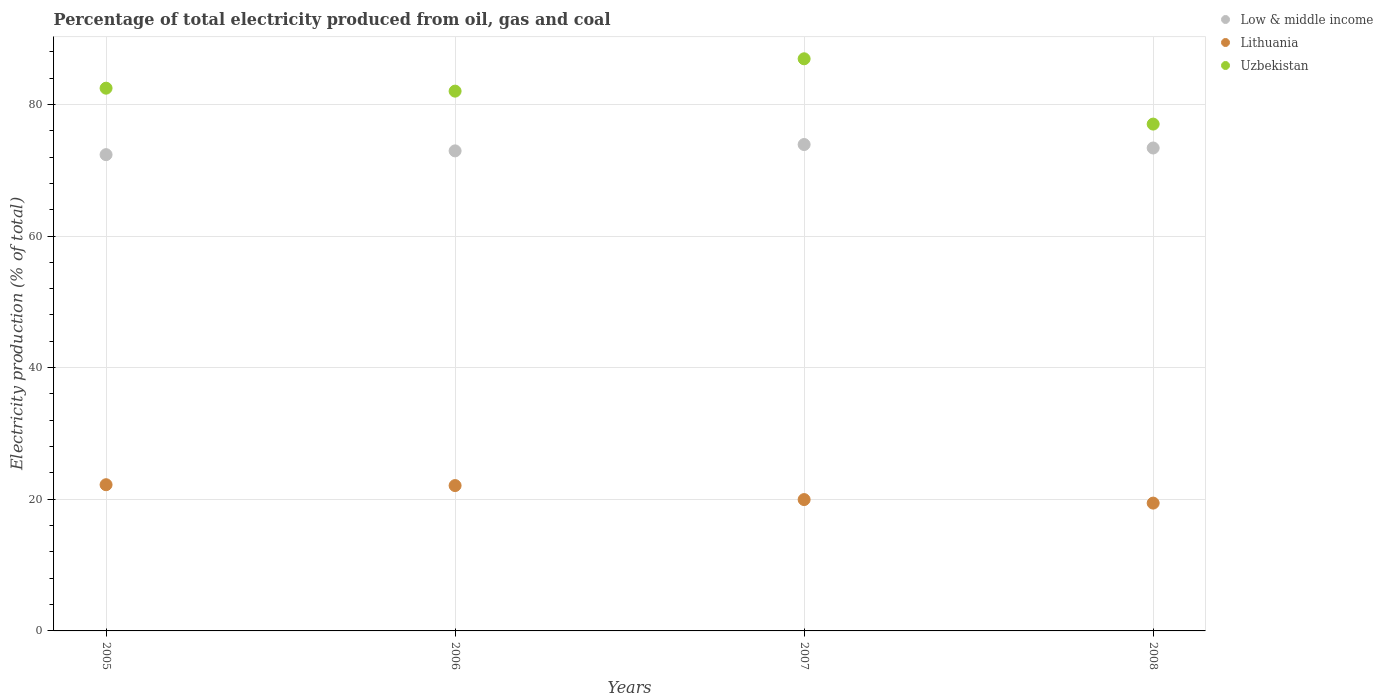Is the number of dotlines equal to the number of legend labels?
Your response must be concise. Yes. What is the electricity production in in Uzbekistan in 2005?
Offer a very short reply. 82.46. Across all years, what is the maximum electricity production in in Lithuania?
Keep it short and to the point. 22.21. Across all years, what is the minimum electricity production in in Lithuania?
Ensure brevity in your answer.  19.42. What is the total electricity production in in Uzbekistan in the graph?
Your answer should be very brief. 328.4. What is the difference between the electricity production in in Uzbekistan in 2007 and that in 2008?
Your answer should be very brief. 9.92. What is the difference between the electricity production in in Low & middle income in 2005 and the electricity production in in Uzbekistan in 2008?
Offer a very short reply. -4.64. What is the average electricity production in in Lithuania per year?
Your response must be concise. 20.92. In the year 2008, what is the difference between the electricity production in in Low & middle income and electricity production in in Lithuania?
Provide a succinct answer. 53.95. What is the ratio of the electricity production in in Low & middle income in 2005 to that in 2006?
Ensure brevity in your answer.  0.99. Is the electricity production in in Uzbekistan in 2005 less than that in 2006?
Keep it short and to the point. No. Is the difference between the electricity production in in Low & middle income in 2005 and 2006 greater than the difference between the electricity production in in Lithuania in 2005 and 2006?
Provide a succinct answer. No. What is the difference between the highest and the second highest electricity production in in Low & middle income?
Keep it short and to the point. 0.53. What is the difference between the highest and the lowest electricity production in in Lithuania?
Offer a very short reply. 2.79. Is it the case that in every year, the sum of the electricity production in in Uzbekistan and electricity production in in Low & middle income  is greater than the electricity production in in Lithuania?
Provide a short and direct response. Yes. Does the electricity production in in Low & middle income monotonically increase over the years?
Give a very brief answer. No. How many years are there in the graph?
Provide a succinct answer. 4. Does the graph contain any zero values?
Keep it short and to the point. No. Where does the legend appear in the graph?
Your response must be concise. Top right. How are the legend labels stacked?
Ensure brevity in your answer.  Vertical. What is the title of the graph?
Your answer should be compact. Percentage of total electricity produced from oil, gas and coal. Does "Senegal" appear as one of the legend labels in the graph?
Provide a short and direct response. No. What is the label or title of the Y-axis?
Make the answer very short. Electricity production (% of total). What is the Electricity production (% of total) of Low & middle income in 2005?
Your response must be concise. 72.36. What is the Electricity production (% of total) of Lithuania in 2005?
Ensure brevity in your answer.  22.21. What is the Electricity production (% of total) in Uzbekistan in 2005?
Provide a succinct answer. 82.46. What is the Electricity production (% of total) in Low & middle income in 2006?
Your response must be concise. 72.94. What is the Electricity production (% of total) in Lithuania in 2006?
Your answer should be compact. 22.08. What is the Electricity production (% of total) of Uzbekistan in 2006?
Make the answer very short. 82.01. What is the Electricity production (% of total) in Low & middle income in 2007?
Give a very brief answer. 73.9. What is the Electricity production (% of total) of Lithuania in 2007?
Offer a very short reply. 19.96. What is the Electricity production (% of total) of Uzbekistan in 2007?
Offer a terse response. 86.93. What is the Electricity production (% of total) of Low & middle income in 2008?
Your answer should be very brief. 73.37. What is the Electricity production (% of total) in Lithuania in 2008?
Make the answer very short. 19.42. What is the Electricity production (% of total) in Uzbekistan in 2008?
Offer a very short reply. 77. Across all years, what is the maximum Electricity production (% of total) in Low & middle income?
Your answer should be compact. 73.9. Across all years, what is the maximum Electricity production (% of total) in Lithuania?
Your answer should be compact. 22.21. Across all years, what is the maximum Electricity production (% of total) of Uzbekistan?
Offer a very short reply. 86.93. Across all years, what is the minimum Electricity production (% of total) in Low & middle income?
Keep it short and to the point. 72.36. Across all years, what is the minimum Electricity production (% of total) in Lithuania?
Keep it short and to the point. 19.42. Across all years, what is the minimum Electricity production (% of total) in Uzbekistan?
Offer a terse response. 77. What is the total Electricity production (% of total) in Low & middle income in the graph?
Give a very brief answer. 292.57. What is the total Electricity production (% of total) in Lithuania in the graph?
Make the answer very short. 83.67. What is the total Electricity production (% of total) of Uzbekistan in the graph?
Provide a succinct answer. 328.4. What is the difference between the Electricity production (% of total) of Low & middle income in 2005 and that in 2006?
Provide a short and direct response. -0.57. What is the difference between the Electricity production (% of total) of Lithuania in 2005 and that in 2006?
Provide a short and direct response. 0.13. What is the difference between the Electricity production (% of total) in Uzbekistan in 2005 and that in 2006?
Offer a very short reply. 0.45. What is the difference between the Electricity production (% of total) of Low & middle income in 2005 and that in 2007?
Give a very brief answer. -1.54. What is the difference between the Electricity production (% of total) of Lithuania in 2005 and that in 2007?
Ensure brevity in your answer.  2.26. What is the difference between the Electricity production (% of total) in Uzbekistan in 2005 and that in 2007?
Ensure brevity in your answer.  -4.47. What is the difference between the Electricity production (% of total) of Low & middle income in 2005 and that in 2008?
Offer a very short reply. -1.01. What is the difference between the Electricity production (% of total) of Lithuania in 2005 and that in 2008?
Your answer should be very brief. 2.79. What is the difference between the Electricity production (% of total) of Uzbekistan in 2005 and that in 2008?
Your answer should be compact. 5.46. What is the difference between the Electricity production (% of total) of Low & middle income in 2006 and that in 2007?
Provide a short and direct response. -0.96. What is the difference between the Electricity production (% of total) in Lithuania in 2006 and that in 2007?
Give a very brief answer. 2.13. What is the difference between the Electricity production (% of total) in Uzbekistan in 2006 and that in 2007?
Provide a succinct answer. -4.91. What is the difference between the Electricity production (% of total) in Low & middle income in 2006 and that in 2008?
Provide a succinct answer. -0.44. What is the difference between the Electricity production (% of total) of Lithuania in 2006 and that in 2008?
Ensure brevity in your answer.  2.66. What is the difference between the Electricity production (% of total) in Uzbekistan in 2006 and that in 2008?
Offer a very short reply. 5.01. What is the difference between the Electricity production (% of total) of Low & middle income in 2007 and that in 2008?
Your response must be concise. 0.53. What is the difference between the Electricity production (% of total) of Lithuania in 2007 and that in 2008?
Provide a short and direct response. 0.54. What is the difference between the Electricity production (% of total) of Uzbekistan in 2007 and that in 2008?
Your response must be concise. 9.92. What is the difference between the Electricity production (% of total) in Low & middle income in 2005 and the Electricity production (% of total) in Lithuania in 2006?
Provide a short and direct response. 50.28. What is the difference between the Electricity production (% of total) in Low & middle income in 2005 and the Electricity production (% of total) in Uzbekistan in 2006?
Your response must be concise. -9.65. What is the difference between the Electricity production (% of total) of Lithuania in 2005 and the Electricity production (% of total) of Uzbekistan in 2006?
Offer a very short reply. -59.8. What is the difference between the Electricity production (% of total) in Low & middle income in 2005 and the Electricity production (% of total) in Lithuania in 2007?
Ensure brevity in your answer.  52.41. What is the difference between the Electricity production (% of total) of Low & middle income in 2005 and the Electricity production (% of total) of Uzbekistan in 2007?
Provide a succinct answer. -14.56. What is the difference between the Electricity production (% of total) of Lithuania in 2005 and the Electricity production (% of total) of Uzbekistan in 2007?
Offer a very short reply. -64.71. What is the difference between the Electricity production (% of total) of Low & middle income in 2005 and the Electricity production (% of total) of Lithuania in 2008?
Make the answer very short. 52.94. What is the difference between the Electricity production (% of total) of Low & middle income in 2005 and the Electricity production (% of total) of Uzbekistan in 2008?
Ensure brevity in your answer.  -4.64. What is the difference between the Electricity production (% of total) of Lithuania in 2005 and the Electricity production (% of total) of Uzbekistan in 2008?
Keep it short and to the point. -54.79. What is the difference between the Electricity production (% of total) in Low & middle income in 2006 and the Electricity production (% of total) in Lithuania in 2007?
Make the answer very short. 52.98. What is the difference between the Electricity production (% of total) in Low & middle income in 2006 and the Electricity production (% of total) in Uzbekistan in 2007?
Offer a very short reply. -13.99. What is the difference between the Electricity production (% of total) of Lithuania in 2006 and the Electricity production (% of total) of Uzbekistan in 2007?
Your answer should be compact. -64.84. What is the difference between the Electricity production (% of total) in Low & middle income in 2006 and the Electricity production (% of total) in Lithuania in 2008?
Provide a short and direct response. 53.52. What is the difference between the Electricity production (% of total) in Low & middle income in 2006 and the Electricity production (% of total) in Uzbekistan in 2008?
Your answer should be compact. -4.07. What is the difference between the Electricity production (% of total) in Lithuania in 2006 and the Electricity production (% of total) in Uzbekistan in 2008?
Your answer should be very brief. -54.92. What is the difference between the Electricity production (% of total) of Low & middle income in 2007 and the Electricity production (% of total) of Lithuania in 2008?
Offer a terse response. 54.48. What is the difference between the Electricity production (% of total) in Low & middle income in 2007 and the Electricity production (% of total) in Uzbekistan in 2008?
Give a very brief answer. -3.1. What is the difference between the Electricity production (% of total) of Lithuania in 2007 and the Electricity production (% of total) of Uzbekistan in 2008?
Keep it short and to the point. -57.05. What is the average Electricity production (% of total) of Low & middle income per year?
Keep it short and to the point. 73.14. What is the average Electricity production (% of total) of Lithuania per year?
Provide a short and direct response. 20.92. What is the average Electricity production (% of total) in Uzbekistan per year?
Offer a very short reply. 82.1. In the year 2005, what is the difference between the Electricity production (% of total) of Low & middle income and Electricity production (% of total) of Lithuania?
Offer a terse response. 50.15. In the year 2005, what is the difference between the Electricity production (% of total) in Low & middle income and Electricity production (% of total) in Uzbekistan?
Offer a terse response. -10.1. In the year 2005, what is the difference between the Electricity production (% of total) in Lithuania and Electricity production (% of total) in Uzbekistan?
Ensure brevity in your answer.  -60.25. In the year 2006, what is the difference between the Electricity production (% of total) of Low & middle income and Electricity production (% of total) of Lithuania?
Provide a succinct answer. 50.85. In the year 2006, what is the difference between the Electricity production (% of total) in Low & middle income and Electricity production (% of total) in Uzbekistan?
Provide a short and direct response. -9.08. In the year 2006, what is the difference between the Electricity production (% of total) in Lithuania and Electricity production (% of total) in Uzbekistan?
Make the answer very short. -59.93. In the year 2007, what is the difference between the Electricity production (% of total) of Low & middle income and Electricity production (% of total) of Lithuania?
Give a very brief answer. 53.94. In the year 2007, what is the difference between the Electricity production (% of total) in Low & middle income and Electricity production (% of total) in Uzbekistan?
Your answer should be compact. -13.03. In the year 2007, what is the difference between the Electricity production (% of total) of Lithuania and Electricity production (% of total) of Uzbekistan?
Give a very brief answer. -66.97. In the year 2008, what is the difference between the Electricity production (% of total) in Low & middle income and Electricity production (% of total) in Lithuania?
Make the answer very short. 53.95. In the year 2008, what is the difference between the Electricity production (% of total) in Low & middle income and Electricity production (% of total) in Uzbekistan?
Provide a short and direct response. -3.63. In the year 2008, what is the difference between the Electricity production (% of total) of Lithuania and Electricity production (% of total) of Uzbekistan?
Offer a very short reply. -57.58. What is the ratio of the Electricity production (% of total) of Lithuania in 2005 to that in 2006?
Offer a very short reply. 1.01. What is the ratio of the Electricity production (% of total) in Low & middle income in 2005 to that in 2007?
Offer a terse response. 0.98. What is the ratio of the Electricity production (% of total) in Lithuania in 2005 to that in 2007?
Offer a very short reply. 1.11. What is the ratio of the Electricity production (% of total) in Uzbekistan in 2005 to that in 2007?
Keep it short and to the point. 0.95. What is the ratio of the Electricity production (% of total) in Low & middle income in 2005 to that in 2008?
Offer a terse response. 0.99. What is the ratio of the Electricity production (% of total) of Lithuania in 2005 to that in 2008?
Your response must be concise. 1.14. What is the ratio of the Electricity production (% of total) of Uzbekistan in 2005 to that in 2008?
Your answer should be compact. 1.07. What is the ratio of the Electricity production (% of total) in Low & middle income in 2006 to that in 2007?
Keep it short and to the point. 0.99. What is the ratio of the Electricity production (% of total) in Lithuania in 2006 to that in 2007?
Offer a terse response. 1.11. What is the ratio of the Electricity production (% of total) in Uzbekistan in 2006 to that in 2007?
Ensure brevity in your answer.  0.94. What is the ratio of the Electricity production (% of total) of Lithuania in 2006 to that in 2008?
Offer a very short reply. 1.14. What is the ratio of the Electricity production (% of total) in Uzbekistan in 2006 to that in 2008?
Your response must be concise. 1.06. What is the ratio of the Electricity production (% of total) in Lithuania in 2007 to that in 2008?
Your answer should be compact. 1.03. What is the ratio of the Electricity production (% of total) of Uzbekistan in 2007 to that in 2008?
Your response must be concise. 1.13. What is the difference between the highest and the second highest Electricity production (% of total) in Low & middle income?
Provide a succinct answer. 0.53. What is the difference between the highest and the second highest Electricity production (% of total) in Lithuania?
Make the answer very short. 0.13. What is the difference between the highest and the second highest Electricity production (% of total) of Uzbekistan?
Your response must be concise. 4.47. What is the difference between the highest and the lowest Electricity production (% of total) in Low & middle income?
Your response must be concise. 1.54. What is the difference between the highest and the lowest Electricity production (% of total) of Lithuania?
Give a very brief answer. 2.79. What is the difference between the highest and the lowest Electricity production (% of total) of Uzbekistan?
Offer a very short reply. 9.92. 